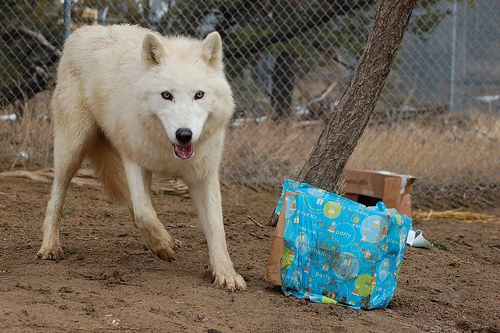<image>
Can you confirm if the fox is to the right of the box? No. The fox is not to the right of the box. The horizontal positioning shows a different relationship. Where is the tree in relation to the fence? Is it in front of the fence? Yes. The tree is positioned in front of the fence, appearing closer to the camera viewpoint. Where is the dog in relation to the ground? Is it in front of the ground? No. The dog is not in front of the ground. The spatial positioning shows a different relationship between these objects. 